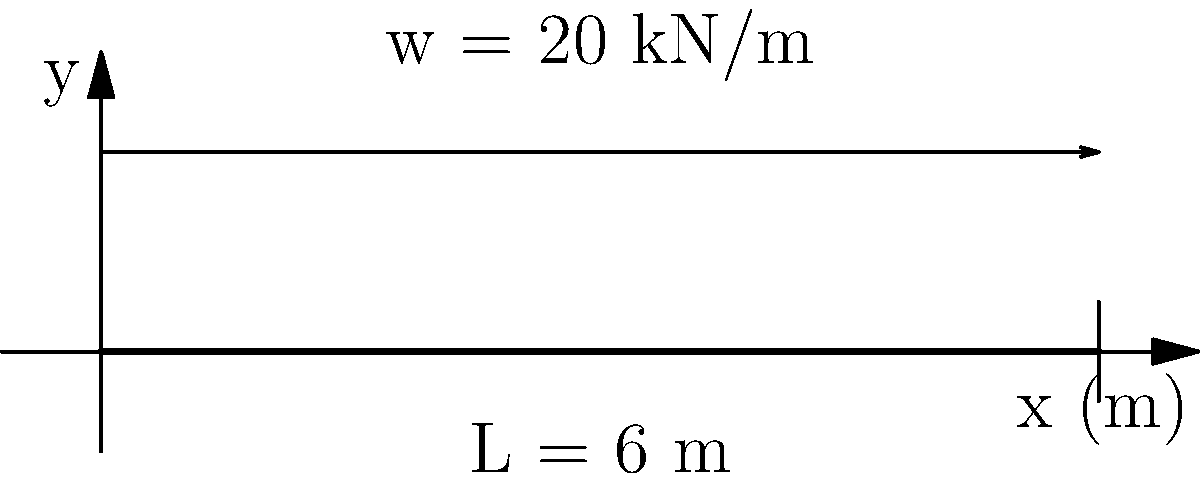Consider a simply supported beam of length 6 m subjected to a uniformly distributed load of 20 kN/m along its entire length. Calculate the maximum bending moment in the beam and sketch the bending moment diagram. To solve this problem, let's follow these steps:

1) First, we need to calculate the reaction forces at the supports:
   Total load = $20 \text{ kN/m} \times 6 \text{ m} = 120 \text{ kN}$
   Due to symmetry, each support reaction will be half of the total load:
   $R_A = R_B = 120 \text{ kN} / 2 = 60 \text{ kN}$

2) The maximum bending moment in a simply supported beam with a uniformly distributed load occurs at the center of the beam. We can calculate it using the formula:

   $M_{max} = \frac{wL^2}{8}$

   where $w$ is the distributed load and $L$ is the length of the beam.

3) Substituting the values:
   $M_{max} = \frac{20 \text{ kN/m} \times (6 \text{ m})^2}{8} = 90 \text{ kN·m}$

4) The bending moment diagram for this case is parabolic, starting from zero at both supports and reaching the maximum value at the center. The equation for the bending moment at any point $x$ along the beam is:

   $M(x) = \frac{wx}{2}(L-x)$

5) To sketch the bending moment diagram:
   - Start at zero at the left support (x = 0)
   - Increase parabolically to 90 kN·m at the center (x = 3 m)
   - Decrease parabolically back to zero at the right support (x = 6 m)

The resulting diagram will be a symmetric parabola with its vertex at the center of the beam.
Answer: Maximum bending moment: 90 kN·m 